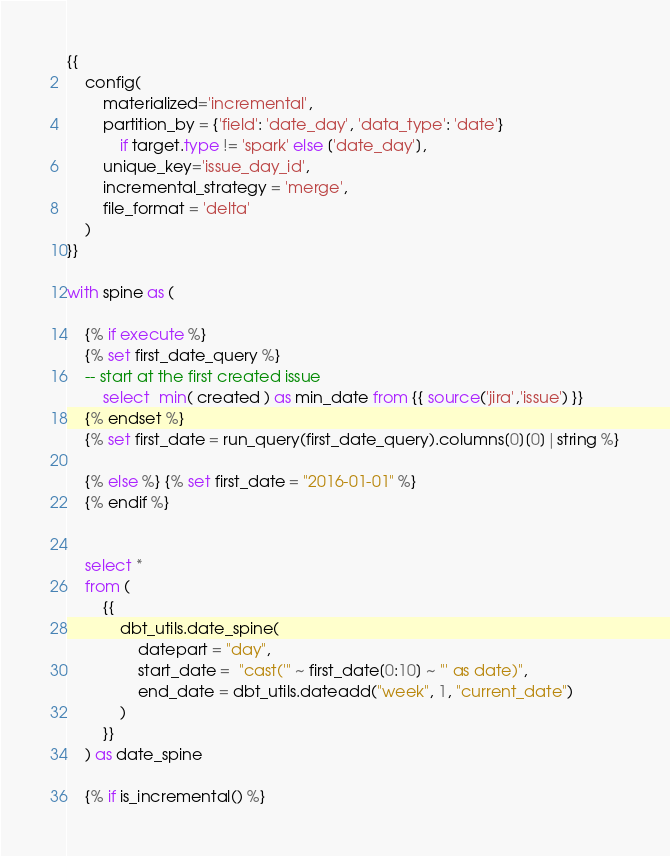Convert code to text. <code><loc_0><loc_0><loc_500><loc_500><_SQL_>{{
    config(
        materialized='incremental',
        partition_by = {'field': 'date_day', 'data_type': 'date'}
            if target.type != 'spark' else ['date_day'],
        unique_key='issue_day_id',
        incremental_strategy = 'merge',
        file_format = 'delta'
    )
}}

with spine as (

    {% if execute %}
    {% set first_date_query %}
    -- start at the first created issue
        select  min( created ) as min_date from {{ source('jira','issue') }}
    {% endset %}
    {% set first_date = run_query(first_date_query).columns[0][0]|string %}
    
    {% else %} {% set first_date = "2016-01-01" %}
    {% endif %}


    select * 
    from (
        {{
            dbt_utils.date_spine(
                datepart = "day", 
                start_date =  "cast('" ~ first_date[0:10] ~ "' as date)", 
                end_date = dbt_utils.dateadd("week", 1, "current_date")
            )   
        }} 
    ) as date_spine

    {% if is_incremental() %}</code> 